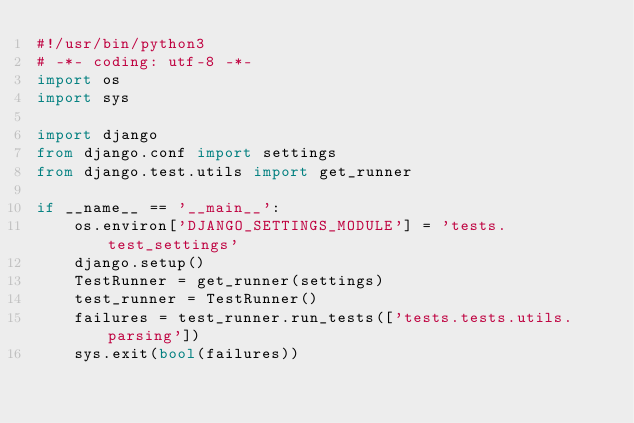<code> <loc_0><loc_0><loc_500><loc_500><_Python_>#!/usr/bin/python3
# -*- coding: utf-8 -*-
import os
import sys

import django
from django.conf import settings
from django.test.utils import get_runner

if __name__ == '__main__':
    os.environ['DJANGO_SETTINGS_MODULE'] = 'tests.test_settings'
    django.setup()
    TestRunner = get_runner(settings)
    test_runner = TestRunner()
    failures = test_runner.run_tests(['tests.tests.utils.parsing'])
    sys.exit(bool(failures))
</code> 